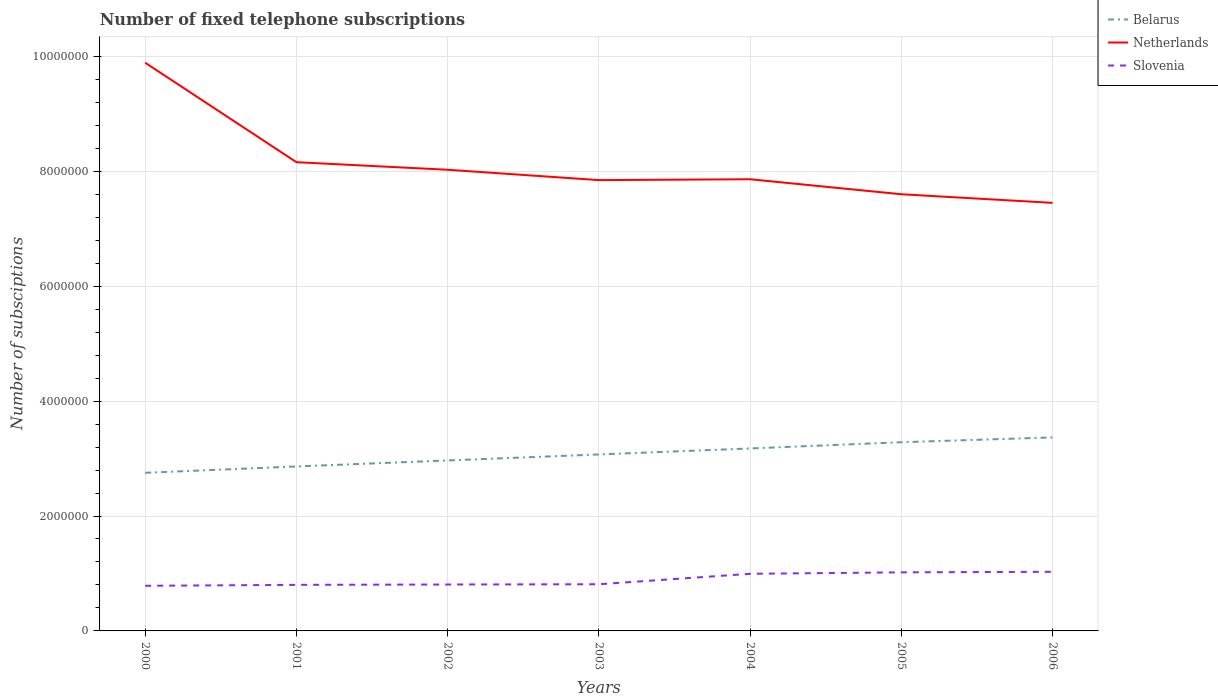Across all years, what is the maximum number of fixed telephone subscriptions in Netherlands?
Provide a succinct answer. 7.45e+06. In which year was the number of fixed telephone subscriptions in Belarus maximum?
Keep it short and to the point. 2000. What is the total number of fixed telephone subscriptions in Netherlands in the graph?
Provide a succinct answer. -1.50e+04. What is the difference between the highest and the second highest number of fixed telephone subscriptions in Netherlands?
Offer a terse response. 2.44e+06. What is the difference between the highest and the lowest number of fixed telephone subscriptions in Slovenia?
Provide a succinct answer. 3. Is the number of fixed telephone subscriptions in Slovenia strictly greater than the number of fixed telephone subscriptions in Netherlands over the years?
Give a very brief answer. Yes. How many lines are there?
Provide a succinct answer. 3. Does the graph contain any zero values?
Your answer should be compact. No. Does the graph contain grids?
Provide a succinct answer. Yes. What is the title of the graph?
Ensure brevity in your answer.  Number of fixed telephone subscriptions. Does "Nicaragua" appear as one of the legend labels in the graph?
Your answer should be very brief. No. What is the label or title of the Y-axis?
Make the answer very short. Number of subsciptions. What is the Number of subsciptions of Belarus in 2000?
Give a very brief answer. 2.75e+06. What is the Number of subsciptions of Netherlands in 2000?
Your answer should be very brief. 9.89e+06. What is the Number of subsciptions in Slovenia in 2000?
Your answer should be compact. 7.85e+05. What is the Number of subsciptions in Belarus in 2001?
Your response must be concise. 2.86e+06. What is the Number of subsciptions in Netherlands in 2001?
Provide a succinct answer. 8.16e+06. What is the Number of subsciptions of Slovenia in 2001?
Your answer should be very brief. 8.02e+05. What is the Number of subsciptions in Belarus in 2002?
Offer a very short reply. 2.97e+06. What is the Number of subsciptions in Netherlands in 2002?
Your response must be concise. 8.03e+06. What is the Number of subsciptions in Slovenia in 2002?
Your answer should be compact. 8.08e+05. What is the Number of subsciptions of Belarus in 2003?
Give a very brief answer. 3.07e+06. What is the Number of subsciptions in Netherlands in 2003?
Ensure brevity in your answer.  7.85e+06. What is the Number of subsciptions in Slovenia in 2003?
Give a very brief answer. 8.12e+05. What is the Number of subsciptions of Belarus in 2004?
Your response must be concise. 3.18e+06. What is the Number of subsciptions in Netherlands in 2004?
Your response must be concise. 7.86e+06. What is the Number of subsciptions in Slovenia in 2004?
Give a very brief answer. 9.94e+05. What is the Number of subsciptions of Belarus in 2005?
Your response must be concise. 3.28e+06. What is the Number of subsciptions of Netherlands in 2005?
Give a very brief answer. 7.60e+06. What is the Number of subsciptions of Slovenia in 2005?
Give a very brief answer. 1.02e+06. What is the Number of subsciptions of Belarus in 2006?
Your answer should be compact. 3.37e+06. What is the Number of subsciptions of Netherlands in 2006?
Provide a short and direct response. 7.45e+06. What is the Number of subsciptions in Slovenia in 2006?
Provide a succinct answer. 1.03e+06. Across all years, what is the maximum Number of subsciptions in Belarus?
Provide a short and direct response. 3.37e+06. Across all years, what is the maximum Number of subsciptions of Netherlands?
Give a very brief answer. 9.89e+06. Across all years, what is the maximum Number of subsciptions in Slovenia?
Offer a very short reply. 1.03e+06. Across all years, what is the minimum Number of subsciptions of Belarus?
Offer a very short reply. 2.75e+06. Across all years, what is the minimum Number of subsciptions in Netherlands?
Your response must be concise. 7.45e+06. Across all years, what is the minimum Number of subsciptions in Slovenia?
Offer a very short reply. 7.85e+05. What is the total Number of subsciptions of Belarus in the graph?
Make the answer very short. 2.15e+07. What is the total Number of subsciptions of Netherlands in the graph?
Your response must be concise. 5.68e+07. What is the total Number of subsciptions in Slovenia in the graph?
Provide a succinct answer. 6.25e+06. What is the difference between the Number of subsciptions in Belarus in 2000 and that in 2001?
Provide a short and direct response. -1.10e+05. What is the difference between the Number of subsciptions of Netherlands in 2000 and that in 2001?
Your response must be concise. 1.73e+06. What is the difference between the Number of subsciptions of Slovenia in 2000 and that in 2001?
Provide a short and direct response. -1.65e+04. What is the difference between the Number of subsciptions in Belarus in 2000 and that in 2002?
Your answer should be compact. -2.15e+05. What is the difference between the Number of subsciptions in Netherlands in 2000 and that in 2002?
Keep it short and to the point. 1.86e+06. What is the difference between the Number of subsciptions in Slovenia in 2000 and that in 2002?
Keep it short and to the point. -2.24e+04. What is the difference between the Number of subsciptions of Belarus in 2000 and that in 2003?
Make the answer very short. -3.19e+05. What is the difference between the Number of subsciptions in Netherlands in 2000 and that in 2003?
Your answer should be very brief. 2.04e+06. What is the difference between the Number of subsciptions of Slovenia in 2000 and that in 2003?
Ensure brevity in your answer.  -2.69e+04. What is the difference between the Number of subsciptions of Belarus in 2000 and that in 2004?
Offer a terse response. -4.24e+05. What is the difference between the Number of subsciptions in Netherlands in 2000 and that in 2004?
Give a very brief answer. 2.03e+06. What is the difference between the Number of subsciptions in Slovenia in 2000 and that in 2004?
Keep it short and to the point. -2.09e+05. What is the difference between the Number of subsciptions of Belarus in 2000 and that in 2005?
Ensure brevity in your answer.  -5.32e+05. What is the difference between the Number of subsciptions of Netherlands in 2000 and that in 2005?
Provide a succinct answer. 2.29e+06. What is the difference between the Number of subsciptions of Slovenia in 2000 and that in 2005?
Make the answer very short. -2.34e+05. What is the difference between the Number of subsciptions in Belarus in 2000 and that in 2006?
Your response must be concise. -6.16e+05. What is the difference between the Number of subsciptions of Netherlands in 2000 and that in 2006?
Offer a terse response. 2.44e+06. What is the difference between the Number of subsciptions in Slovenia in 2000 and that in 2006?
Provide a short and direct response. -2.44e+05. What is the difference between the Number of subsciptions of Belarus in 2001 and that in 2002?
Provide a short and direct response. -1.05e+05. What is the difference between the Number of subsciptions of Netherlands in 2001 and that in 2002?
Your answer should be very brief. 1.32e+05. What is the difference between the Number of subsciptions in Slovenia in 2001 and that in 2002?
Provide a succinct answer. -5910. What is the difference between the Number of subsciptions in Belarus in 2001 and that in 2003?
Your answer should be compact. -2.09e+05. What is the difference between the Number of subsciptions in Netherlands in 2001 and that in 2003?
Offer a terse response. 3.12e+05. What is the difference between the Number of subsciptions in Slovenia in 2001 and that in 2003?
Your response must be concise. -1.04e+04. What is the difference between the Number of subsciptions of Belarus in 2001 and that in 2004?
Make the answer very short. -3.14e+05. What is the difference between the Number of subsciptions in Netherlands in 2001 and that in 2004?
Keep it short and to the point. 2.97e+05. What is the difference between the Number of subsciptions in Slovenia in 2001 and that in 2004?
Offer a terse response. -1.93e+05. What is the difference between the Number of subsciptions in Belarus in 2001 and that in 2005?
Provide a short and direct response. -4.22e+05. What is the difference between the Number of subsciptions of Netherlands in 2001 and that in 2005?
Give a very brief answer. 5.58e+05. What is the difference between the Number of subsciptions in Slovenia in 2001 and that in 2005?
Your answer should be compact. -2.18e+05. What is the difference between the Number of subsciptions of Belarus in 2001 and that in 2006?
Make the answer very short. -5.06e+05. What is the difference between the Number of subsciptions of Netherlands in 2001 and that in 2006?
Offer a terse response. 7.08e+05. What is the difference between the Number of subsciptions in Slovenia in 2001 and that in 2006?
Offer a very short reply. -2.27e+05. What is the difference between the Number of subsciptions of Belarus in 2002 and that in 2003?
Provide a succinct answer. -1.04e+05. What is the difference between the Number of subsciptions in Slovenia in 2002 and that in 2003?
Ensure brevity in your answer.  -4535. What is the difference between the Number of subsciptions in Belarus in 2002 and that in 2004?
Provide a succinct answer. -2.09e+05. What is the difference between the Number of subsciptions in Netherlands in 2002 and that in 2004?
Provide a short and direct response. 1.65e+05. What is the difference between the Number of subsciptions of Slovenia in 2002 and that in 2004?
Provide a succinct answer. -1.87e+05. What is the difference between the Number of subsciptions of Belarus in 2002 and that in 2005?
Provide a short and direct response. -3.17e+05. What is the difference between the Number of subsciptions of Netherlands in 2002 and that in 2005?
Your response must be concise. 4.26e+05. What is the difference between the Number of subsciptions of Slovenia in 2002 and that in 2005?
Your answer should be very brief. -2.12e+05. What is the difference between the Number of subsciptions in Belarus in 2002 and that in 2006?
Your answer should be very brief. -4.01e+05. What is the difference between the Number of subsciptions of Netherlands in 2002 and that in 2006?
Give a very brief answer. 5.76e+05. What is the difference between the Number of subsciptions in Slovenia in 2002 and that in 2006?
Keep it short and to the point. -2.21e+05. What is the difference between the Number of subsciptions of Belarus in 2003 and that in 2004?
Offer a terse response. -1.05e+05. What is the difference between the Number of subsciptions in Netherlands in 2003 and that in 2004?
Your response must be concise. -1.50e+04. What is the difference between the Number of subsciptions in Slovenia in 2003 and that in 2004?
Your response must be concise. -1.82e+05. What is the difference between the Number of subsciptions in Belarus in 2003 and that in 2005?
Your response must be concise. -2.13e+05. What is the difference between the Number of subsciptions in Netherlands in 2003 and that in 2005?
Give a very brief answer. 2.46e+05. What is the difference between the Number of subsciptions of Slovenia in 2003 and that in 2005?
Make the answer very short. -2.07e+05. What is the difference between the Number of subsciptions of Belarus in 2003 and that in 2006?
Your answer should be very brief. -2.97e+05. What is the difference between the Number of subsciptions in Netherlands in 2003 and that in 2006?
Your answer should be very brief. 3.96e+05. What is the difference between the Number of subsciptions in Slovenia in 2003 and that in 2006?
Give a very brief answer. -2.17e+05. What is the difference between the Number of subsciptions of Belarus in 2004 and that in 2005?
Your answer should be very brief. -1.08e+05. What is the difference between the Number of subsciptions in Netherlands in 2004 and that in 2005?
Keep it short and to the point. 2.61e+05. What is the difference between the Number of subsciptions in Slovenia in 2004 and that in 2005?
Your answer should be very brief. -2.50e+04. What is the difference between the Number of subsciptions in Belarus in 2004 and that in 2006?
Provide a succinct answer. -1.92e+05. What is the difference between the Number of subsciptions in Netherlands in 2004 and that in 2006?
Give a very brief answer. 4.11e+05. What is the difference between the Number of subsciptions of Slovenia in 2004 and that in 2006?
Your answer should be very brief. -3.46e+04. What is the difference between the Number of subsciptions in Belarus in 2005 and that in 2006?
Provide a succinct answer. -8.37e+04. What is the difference between the Number of subsciptions of Netherlands in 2005 and that in 2006?
Ensure brevity in your answer.  1.50e+05. What is the difference between the Number of subsciptions of Slovenia in 2005 and that in 2006?
Your answer should be very brief. -9619. What is the difference between the Number of subsciptions of Belarus in 2000 and the Number of subsciptions of Netherlands in 2001?
Your answer should be very brief. -5.41e+06. What is the difference between the Number of subsciptions of Belarus in 2000 and the Number of subsciptions of Slovenia in 2001?
Your response must be concise. 1.95e+06. What is the difference between the Number of subsciptions of Netherlands in 2000 and the Number of subsciptions of Slovenia in 2001?
Your answer should be compact. 9.09e+06. What is the difference between the Number of subsciptions of Belarus in 2000 and the Number of subsciptions of Netherlands in 2002?
Offer a terse response. -5.27e+06. What is the difference between the Number of subsciptions in Belarus in 2000 and the Number of subsciptions in Slovenia in 2002?
Offer a terse response. 1.94e+06. What is the difference between the Number of subsciptions in Netherlands in 2000 and the Number of subsciptions in Slovenia in 2002?
Offer a very short reply. 9.08e+06. What is the difference between the Number of subsciptions in Belarus in 2000 and the Number of subsciptions in Netherlands in 2003?
Provide a succinct answer. -5.09e+06. What is the difference between the Number of subsciptions in Belarus in 2000 and the Number of subsciptions in Slovenia in 2003?
Offer a terse response. 1.94e+06. What is the difference between the Number of subsciptions of Netherlands in 2000 and the Number of subsciptions of Slovenia in 2003?
Give a very brief answer. 9.08e+06. What is the difference between the Number of subsciptions of Belarus in 2000 and the Number of subsciptions of Netherlands in 2004?
Keep it short and to the point. -5.11e+06. What is the difference between the Number of subsciptions of Belarus in 2000 and the Number of subsciptions of Slovenia in 2004?
Offer a terse response. 1.76e+06. What is the difference between the Number of subsciptions of Netherlands in 2000 and the Number of subsciptions of Slovenia in 2004?
Your answer should be very brief. 8.89e+06. What is the difference between the Number of subsciptions of Belarus in 2000 and the Number of subsciptions of Netherlands in 2005?
Keep it short and to the point. -4.85e+06. What is the difference between the Number of subsciptions of Belarus in 2000 and the Number of subsciptions of Slovenia in 2005?
Your answer should be compact. 1.73e+06. What is the difference between the Number of subsciptions in Netherlands in 2000 and the Number of subsciptions in Slovenia in 2005?
Your answer should be compact. 8.87e+06. What is the difference between the Number of subsciptions in Belarus in 2000 and the Number of subsciptions in Netherlands in 2006?
Make the answer very short. -4.70e+06. What is the difference between the Number of subsciptions in Belarus in 2000 and the Number of subsciptions in Slovenia in 2006?
Ensure brevity in your answer.  1.72e+06. What is the difference between the Number of subsciptions of Netherlands in 2000 and the Number of subsciptions of Slovenia in 2006?
Provide a short and direct response. 8.86e+06. What is the difference between the Number of subsciptions of Belarus in 2001 and the Number of subsciptions of Netherlands in 2002?
Your answer should be very brief. -5.16e+06. What is the difference between the Number of subsciptions in Belarus in 2001 and the Number of subsciptions in Slovenia in 2002?
Provide a succinct answer. 2.05e+06. What is the difference between the Number of subsciptions of Netherlands in 2001 and the Number of subsciptions of Slovenia in 2002?
Your response must be concise. 7.35e+06. What is the difference between the Number of subsciptions of Belarus in 2001 and the Number of subsciptions of Netherlands in 2003?
Ensure brevity in your answer.  -4.98e+06. What is the difference between the Number of subsciptions in Belarus in 2001 and the Number of subsciptions in Slovenia in 2003?
Provide a short and direct response. 2.05e+06. What is the difference between the Number of subsciptions of Netherlands in 2001 and the Number of subsciptions of Slovenia in 2003?
Offer a terse response. 7.35e+06. What is the difference between the Number of subsciptions in Belarus in 2001 and the Number of subsciptions in Netherlands in 2004?
Provide a short and direct response. -5.00e+06. What is the difference between the Number of subsciptions in Belarus in 2001 and the Number of subsciptions in Slovenia in 2004?
Provide a succinct answer. 1.87e+06. What is the difference between the Number of subsciptions of Netherlands in 2001 and the Number of subsciptions of Slovenia in 2004?
Give a very brief answer. 7.16e+06. What is the difference between the Number of subsciptions of Belarus in 2001 and the Number of subsciptions of Netherlands in 2005?
Provide a short and direct response. -4.74e+06. What is the difference between the Number of subsciptions of Belarus in 2001 and the Number of subsciptions of Slovenia in 2005?
Make the answer very short. 1.84e+06. What is the difference between the Number of subsciptions in Netherlands in 2001 and the Number of subsciptions in Slovenia in 2005?
Give a very brief answer. 7.14e+06. What is the difference between the Number of subsciptions in Belarus in 2001 and the Number of subsciptions in Netherlands in 2006?
Offer a terse response. -4.59e+06. What is the difference between the Number of subsciptions of Belarus in 2001 and the Number of subsciptions of Slovenia in 2006?
Offer a very short reply. 1.83e+06. What is the difference between the Number of subsciptions of Netherlands in 2001 and the Number of subsciptions of Slovenia in 2006?
Provide a short and direct response. 7.13e+06. What is the difference between the Number of subsciptions of Belarus in 2002 and the Number of subsciptions of Netherlands in 2003?
Provide a short and direct response. -4.88e+06. What is the difference between the Number of subsciptions of Belarus in 2002 and the Number of subsciptions of Slovenia in 2003?
Offer a very short reply. 2.15e+06. What is the difference between the Number of subsciptions of Netherlands in 2002 and the Number of subsciptions of Slovenia in 2003?
Give a very brief answer. 7.21e+06. What is the difference between the Number of subsciptions of Belarus in 2002 and the Number of subsciptions of Netherlands in 2004?
Offer a terse response. -4.89e+06. What is the difference between the Number of subsciptions in Belarus in 2002 and the Number of subsciptions in Slovenia in 2004?
Provide a short and direct response. 1.97e+06. What is the difference between the Number of subsciptions of Netherlands in 2002 and the Number of subsciptions of Slovenia in 2004?
Your response must be concise. 7.03e+06. What is the difference between the Number of subsciptions of Belarus in 2002 and the Number of subsciptions of Netherlands in 2005?
Offer a terse response. -4.63e+06. What is the difference between the Number of subsciptions in Belarus in 2002 and the Number of subsciptions in Slovenia in 2005?
Your response must be concise. 1.95e+06. What is the difference between the Number of subsciptions in Netherlands in 2002 and the Number of subsciptions in Slovenia in 2005?
Your answer should be compact. 7.01e+06. What is the difference between the Number of subsciptions of Belarus in 2002 and the Number of subsciptions of Netherlands in 2006?
Offer a very short reply. -4.48e+06. What is the difference between the Number of subsciptions in Belarus in 2002 and the Number of subsciptions in Slovenia in 2006?
Offer a terse response. 1.94e+06. What is the difference between the Number of subsciptions in Netherlands in 2002 and the Number of subsciptions in Slovenia in 2006?
Keep it short and to the point. 7.00e+06. What is the difference between the Number of subsciptions in Belarus in 2003 and the Number of subsciptions in Netherlands in 2004?
Keep it short and to the point. -4.79e+06. What is the difference between the Number of subsciptions of Belarus in 2003 and the Number of subsciptions of Slovenia in 2004?
Provide a short and direct response. 2.08e+06. What is the difference between the Number of subsciptions of Netherlands in 2003 and the Number of subsciptions of Slovenia in 2004?
Offer a very short reply. 6.85e+06. What is the difference between the Number of subsciptions of Belarus in 2003 and the Number of subsciptions of Netherlands in 2005?
Give a very brief answer. -4.53e+06. What is the difference between the Number of subsciptions in Belarus in 2003 and the Number of subsciptions in Slovenia in 2005?
Your response must be concise. 2.05e+06. What is the difference between the Number of subsciptions of Netherlands in 2003 and the Number of subsciptions of Slovenia in 2005?
Ensure brevity in your answer.  6.83e+06. What is the difference between the Number of subsciptions of Belarus in 2003 and the Number of subsciptions of Netherlands in 2006?
Provide a succinct answer. -4.38e+06. What is the difference between the Number of subsciptions in Belarus in 2003 and the Number of subsciptions in Slovenia in 2006?
Offer a very short reply. 2.04e+06. What is the difference between the Number of subsciptions of Netherlands in 2003 and the Number of subsciptions of Slovenia in 2006?
Make the answer very short. 6.82e+06. What is the difference between the Number of subsciptions of Belarus in 2004 and the Number of subsciptions of Netherlands in 2005?
Offer a very short reply. -4.42e+06. What is the difference between the Number of subsciptions of Belarus in 2004 and the Number of subsciptions of Slovenia in 2005?
Your answer should be very brief. 2.16e+06. What is the difference between the Number of subsciptions in Netherlands in 2004 and the Number of subsciptions in Slovenia in 2005?
Keep it short and to the point. 6.84e+06. What is the difference between the Number of subsciptions in Belarus in 2004 and the Number of subsciptions in Netherlands in 2006?
Keep it short and to the point. -4.27e+06. What is the difference between the Number of subsciptions in Belarus in 2004 and the Number of subsciptions in Slovenia in 2006?
Offer a very short reply. 2.15e+06. What is the difference between the Number of subsciptions in Netherlands in 2004 and the Number of subsciptions in Slovenia in 2006?
Provide a short and direct response. 6.83e+06. What is the difference between the Number of subsciptions of Belarus in 2005 and the Number of subsciptions of Netherlands in 2006?
Offer a terse response. -4.17e+06. What is the difference between the Number of subsciptions of Belarus in 2005 and the Number of subsciptions of Slovenia in 2006?
Keep it short and to the point. 2.26e+06. What is the difference between the Number of subsciptions of Netherlands in 2005 and the Number of subsciptions of Slovenia in 2006?
Your response must be concise. 6.57e+06. What is the average Number of subsciptions of Belarus per year?
Your answer should be compact. 3.07e+06. What is the average Number of subsciptions in Netherlands per year?
Provide a succinct answer. 8.12e+06. What is the average Number of subsciptions of Slovenia per year?
Make the answer very short. 8.93e+05. In the year 2000, what is the difference between the Number of subsciptions of Belarus and Number of subsciptions of Netherlands?
Your response must be concise. -7.14e+06. In the year 2000, what is the difference between the Number of subsciptions of Belarus and Number of subsciptions of Slovenia?
Offer a terse response. 1.97e+06. In the year 2000, what is the difference between the Number of subsciptions of Netherlands and Number of subsciptions of Slovenia?
Your response must be concise. 9.10e+06. In the year 2001, what is the difference between the Number of subsciptions in Belarus and Number of subsciptions in Netherlands?
Keep it short and to the point. -5.30e+06. In the year 2001, what is the difference between the Number of subsciptions in Belarus and Number of subsciptions in Slovenia?
Keep it short and to the point. 2.06e+06. In the year 2001, what is the difference between the Number of subsciptions in Netherlands and Number of subsciptions in Slovenia?
Provide a succinct answer. 7.36e+06. In the year 2002, what is the difference between the Number of subsciptions of Belarus and Number of subsciptions of Netherlands?
Offer a very short reply. -5.06e+06. In the year 2002, what is the difference between the Number of subsciptions of Belarus and Number of subsciptions of Slovenia?
Give a very brief answer. 2.16e+06. In the year 2002, what is the difference between the Number of subsciptions in Netherlands and Number of subsciptions in Slovenia?
Provide a short and direct response. 7.22e+06. In the year 2003, what is the difference between the Number of subsciptions in Belarus and Number of subsciptions in Netherlands?
Keep it short and to the point. -4.77e+06. In the year 2003, what is the difference between the Number of subsciptions of Belarus and Number of subsciptions of Slovenia?
Provide a short and direct response. 2.26e+06. In the year 2003, what is the difference between the Number of subsciptions in Netherlands and Number of subsciptions in Slovenia?
Provide a succinct answer. 7.03e+06. In the year 2004, what is the difference between the Number of subsciptions of Belarus and Number of subsciptions of Netherlands?
Keep it short and to the point. -4.69e+06. In the year 2004, what is the difference between the Number of subsciptions in Belarus and Number of subsciptions in Slovenia?
Your answer should be compact. 2.18e+06. In the year 2004, what is the difference between the Number of subsciptions of Netherlands and Number of subsciptions of Slovenia?
Offer a terse response. 6.87e+06. In the year 2005, what is the difference between the Number of subsciptions in Belarus and Number of subsciptions in Netherlands?
Provide a succinct answer. -4.32e+06. In the year 2005, what is the difference between the Number of subsciptions in Belarus and Number of subsciptions in Slovenia?
Offer a very short reply. 2.26e+06. In the year 2005, what is the difference between the Number of subsciptions of Netherlands and Number of subsciptions of Slovenia?
Provide a short and direct response. 6.58e+06. In the year 2006, what is the difference between the Number of subsciptions of Belarus and Number of subsciptions of Netherlands?
Provide a short and direct response. -4.08e+06. In the year 2006, what is the difference between the Number of subsciptions of Belarus and Number of subsciptions of Slovenia?
Provide a short and direct response. 2.34e+06. In the year 2006, what is the difference between the Number of subsciptions in Netherlands and Number of subsciptions in Slovenia?
Provide a short and direct response. 6.42e+06. What is the ratio of the Number of subsciptions of Belarus in 2000 to that in 2001?
Your answer should be very brief. 0.96. What is the ratio of the Number of subsciptions in Netherlands in 2000 to that in 2001?
Provide a succinct answer. 1.21. What is the ratio of the Number of subsciptions of Slovenia in 2000 to that in 2001?
Offer a terse response. 0.98. What is the ratio of the Number of subsciptions of Belarus in 2000 to that in 2002?
Provide a short and direct response. 0.93. What is the ratio of the Number of subsciptions of Netherlands in 2000 to that in 2002?
Your response must be concise. 1.23. What is the ratio of the Number of subsciptions of Slovenia in 2000 to that in 2002?
Keep it short and to the point. 0.97. What is the ratio of the Number of subsciptions of Belarus in 2000 to that in 2003?
Provide a succinct answer. 0.9. What is the ratio of the Number of subsciptions of Netherlands in 2000 to that in 2003?
Your answer should be compact. 1.26. What is the ratio of the Number of subsciptions of Slovenia in 2000 to that in 2003?
Offer a terse response. 0.97. What is the ratio of the Number of subsciptions in Belarus in 2000 to that in 2004?
Your response must be concise. 0.87. What is the ratio of the Number of subsciptions of Netherlands in 2000 to that in 2004?
Provide a short and direct response. 1.26. What is the ratio of the Number of subsciptions in Slovenia in 2000 to that in 2004?
Keep it short and to the point. 0.79. What is the ratio of the Number of subsciptions of Belarus in 2000 to that in 2005?
Make the answer very short. 0.84. What is the ratio of the Number of subsciptions of Netherlands in 2000 to that in 2005?
Provide a short and direct response. 1.3. What is the ratio of the Number of subsciptions of Slovenia in 2000 to that in 2005?
Offer a very short reply. 0.77. What is the ratio of the Number of subsciptions in Belarus in 2000 to that in 2006?
Provide a succinct answer. 0.82. What is the ratio of the Number of subsciptions in Netherlands in 2000 to that in 2006?
Your response must be concise. 1.33. What is the ratio of the Number of subsciptions in Slovenia in 2000 to that in 2006?
Offer a very short reply. 0.76. What is the ratio of the Number of subsciptions in Belarus in 2001 to that in 2002?
Provide a short and direct response. 0.96. What is the ratio of the Number of subsciptions of Netherlands in 2001 to that in 2002?
Provide a succinct answer. 1.02. What is the ratio of the Number of subsciptions of Belarus in 2001 to that in 2003?
Ensure brevity in your answer.  0.93. What is the ratio of the Number of subsciptions in Netherlands in 2001 to that in 2003?
Your response must be concise. 1.04. What is the ratio of the Number of subsciptions of Slovenia in 2001 to that in 2003?
Offer a very short reply. 0.99. What is the ratio of the Number of subsciptions of Belarus in 2001 to that in 2004?
Provide a short and direct response. 0.9. What is the ratio of the Number of subsciptions of Netherlands in 2001 to that in 2004?
Your answer should be very brief. 1.04. What is the ratio of the Number of subsciptions of Slovenia in 2001 to that in 2004?
Give a very brief answer. 0.81. What is the ratio of the Number of subsciptions of Belarus in 2001 to that in 2005?
Offer a very short reply. 0.87. What is the ratio of the Number of subsciptions of Netherlands in 2001 to that in 2005?
Your response must be concise. 1.07. What is the ratio of the Number of subsciptions of Slovenia in 2001 to that in 2005?
Keep it short and to the point. 0.79. What is the ratio of the Number of subsciptions in Belarus in 2001 to that in 2006?
Keep it short and to the point. 0.85. What is the ratio of the Number of subsciptions in Netherlands in 2001 to that in 2006?
Make the answer very short. 1.09. What is the ratio of the Number of subsciptions of Slovenia in 2001 to that in 2006?
Keep it short and to the point. 0.78. What is the ratio of the Number of subsciptions in Belarus in 2002 to that in 2003?
Your answer should be compact. 0.97. What is the ratio of the Number of subsciptions of Netherlands in 2002 to that in 2003?
Your response must be concise. 1.02. What is the ratio of the Number of subsciptions in Belarus in 2002 to that in 2004?
Your response must be concise. 0.93. What is the ratio of the Number of subsciptions in Netherlands in 2002 to that in 2004?
Make the answer very short. 1.02. What is the ratio of the Number of subsciptions of Slovenia in 2002 to that in 2004?
Offer a very short reply. 0.81. What is the ratio of the Number of subsciptions in Belarus in 2002 to that in 2005?
Offer a very short reply. 0.9. What is the ratio of the Number of subsciptions in Netherlands in 2002 to that in 2005?
Provide a succinct answer. 1.06. What is the ratio of the Number of subsciptions of Slovenia in 2002 to that in 2005?
Give a very brief answer. 0.79. What is the ratio of the Number of subsciptions of Belarus in 2002 to that in 2006?
Give a very brief answer. 0.88. What is the ratio of the Number of subsciptions in Netherlands in 2002 to that in 2006?
Offer a very short reply. 1.08. What is the ratio of the Number of subsciptions of Slovenia in 2002 to that in 2006?
Make the answer very short. 0.79. What is the ratio of the Number of subsciptions of Belarus in 2003 to that in 2004?
Give a very brief answer. 0.97. What is the ratio of the Number of subsciptions in Netherlands in 2003 to that in 2004?
Offer a terse response. 1. What is the ratio of the Number of subsciptions of Slovenia in 2003 to that in 2004?
Your response must be concise. 0.82. What is the ratio of the Number of subsciptions in Belarus in 2003 to that in 2005?
Offer a very short reply. 0.94. What is the ratio of the Number of subsciptions of Netherlands in 2003 to that in 2005?
Provide a short and direct response. 1.03. What is the ratio of the Number of subsciptions in Slovenia in 2003 to that in 2005?
Make the answer very short. 0.8. What is the ratio of the Number of subsciptions of Belarus in 2003 to that in 2006?
Provide a short and direct response. 0.91. What is the ratio of the Number of subsciptions of Netherlands in 2003 to that in 2006?
Your response must be concise. 1.05. What is the ratio of the Number of subsciptions in Slovenia in 2003 to that in 2006?
Make the answer very short. 0.79. What is the ratio of the Number of subsciptions in Netherlands in 2004 to that in 2005?
Offer a terse response. 1.03. What is the ratio of the Number of subsciptions of Slovenia in 2004 to that in 2005?
Your answer should be very brief. 0.98. What is the ratio of the Number of subsciptions of Belarus in 2004 to that in 2006?
Your answer should be very brief. 0.94. What is the ratio of the Number of subsciptions in Netherlands in 2004 to that in 2006?
Your answer should be compact. 1.06. What is the ratio of the Number of subsciptions in Slovenia in 2004 to that in 2006?
Ensure brevity in your answer.  0.97. What is the ratio of the Number of subsciptions in Belarus in 2005 to that in 2006?
Ensure brevity in your answer.  0.98. What is the ratio of the Number of subsciptions in Netherlands in 2005 to that in 2006?
Keep it short and to the point. 1.02. What is the difference between the highest and the second highest Number of subsciptions of Belarus?
Offer a very short reply. 8.37e+04. What is the difference between the highest and the second highest Number of subsciptions of Netherlands?
Keep it short and to the point. 1.73e+06. What is the difference between the highest and the second highest Number of subsciptions of Slovenia?
Your response must be concise. 9619. What is the difference between the highest and the lowest Number of subsciptions of Belarus?
Provide a short and direct response. 6.16e+05. What is the difference between the highest and the lowest Number of subsciptions of Netherlands?
Ensure brevity in your answer.  2.44e+06. What is the difference between the highest and the lowest Number of subsciptions of Slovenia?
Your answer should be very brief. 2.44e+05. 